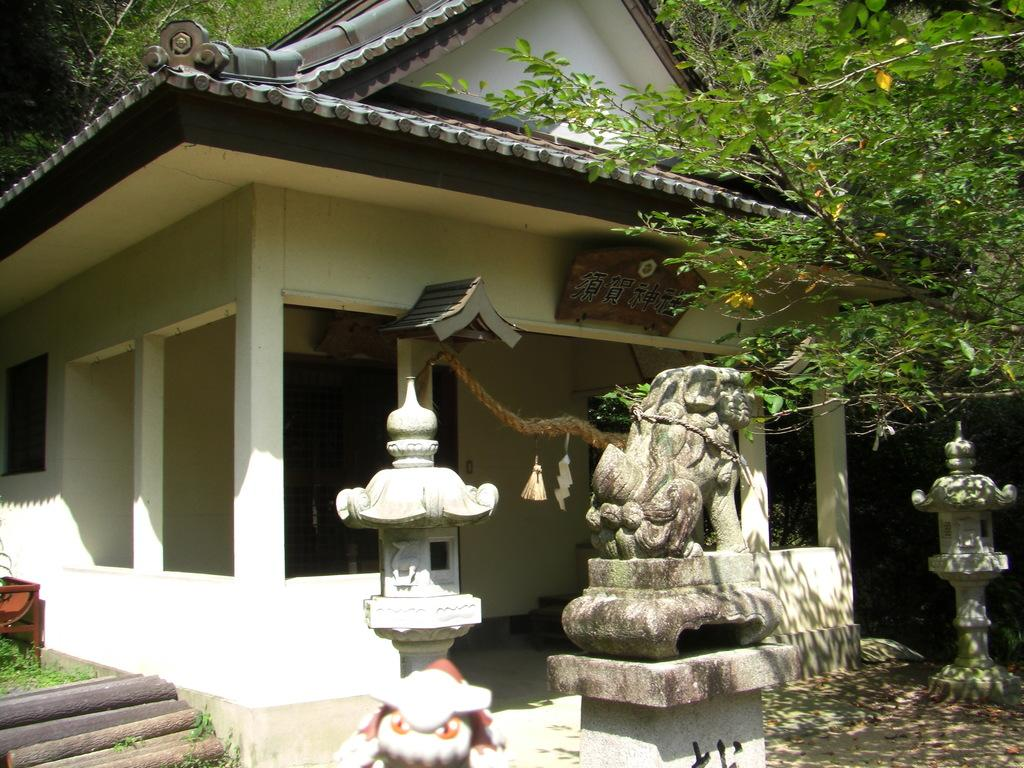What type of structure is visible in the image? There is a house in the image. What architectural feature can be seen in the image? There is a window in the image. What object is present that might be used for tying or hanging? There is a rope in the image. What can be seen with text or writing on it? There is a board with text in the image. What type of support structure is present in the image? There are pillars in the image. What type of artwork can be seen in the image? There are sculptures in the image. What type of material is present in the image that might be used for construction or crafting? There are wooden sticks in the image. What type of furniture is visible in the image? There is a chair in the image. What type of living organisms can be seen in the image? There are plants and trees in the image. Where is the hydrant located in the image? There is no hydrant present in the image. What type of development can be seen in the image? The image does not depict any development or construction process. 